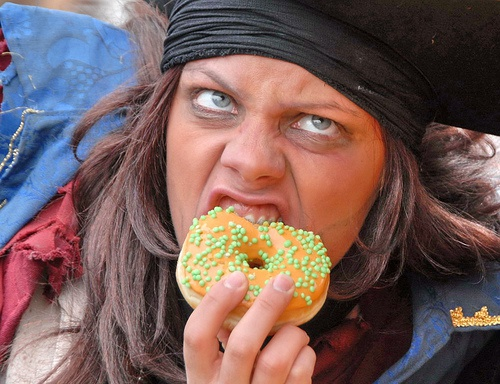Describe the objects in this image and their specific colors. I can see people in black, gray, lightpink, and brown tones and donut in gray, orange, khaki, and lightgreen tones in this image. 